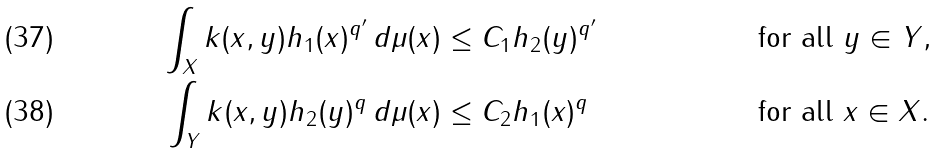Convert formula to latex. <formula><loc_0><loc_0><loc_500><loc_500>\int _ { X } k ( x , y ) h _ { 1 } ( x ) ^ { q ^ { \prime } } \, d \mu ( x ) & \leq C _ { 1 } h _ { 2 } ( y ) ^ { q ^ { \prime } } & & \text {for all } y \in Y , \\ \int _ { Y } k ( x , y ) h _ { 2 } ( y ) ^ { q } \, d \mu ( x ) & \leq C _ { 2 } h _ { 1 } ( x ) ^ { q } & & \text {for all } x \in X .</formula> 